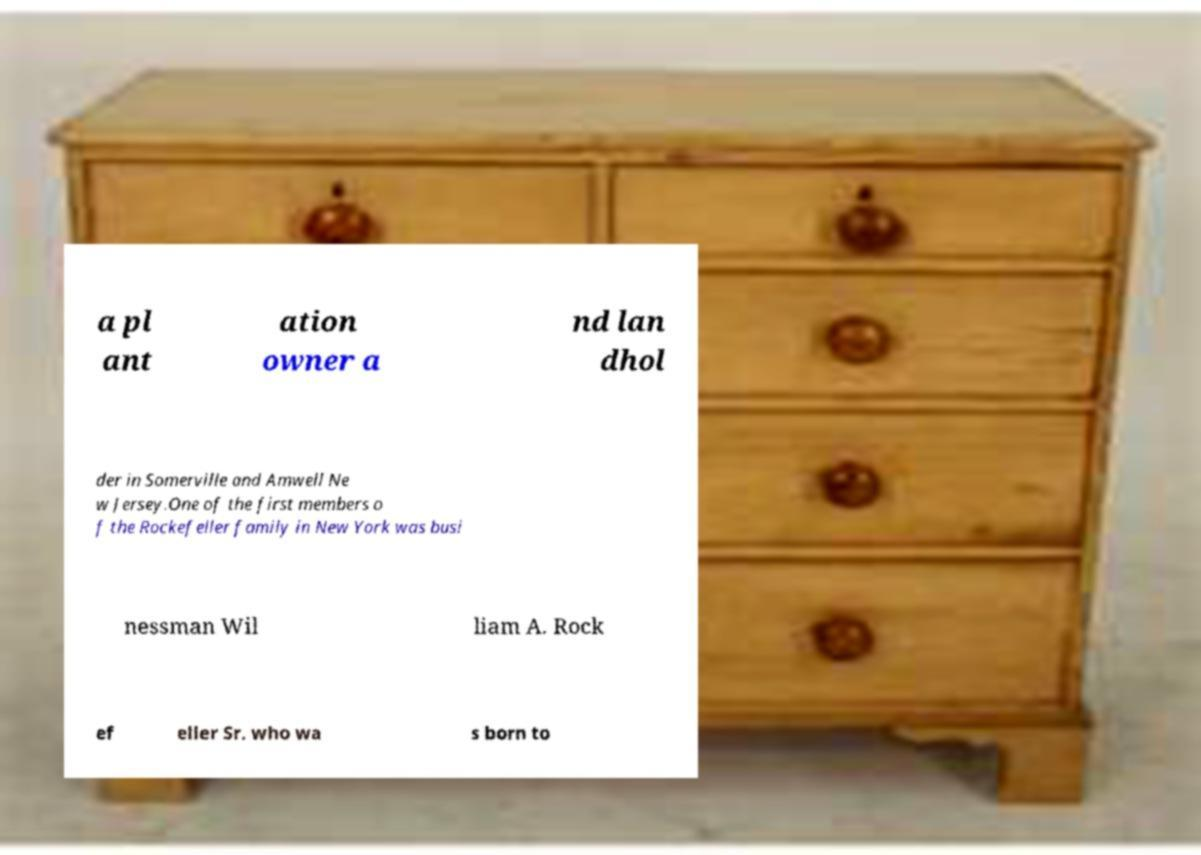Please read and relay the text visible in this image. What does it say? a pl ant ation owner a nd lan dhol der in Somerville and Amwell Ne w Jersey.One of the first members o f the Rockefeller family in New York was busi nessman Wil liam A. Rock ef eller Sr. who wa s born to 